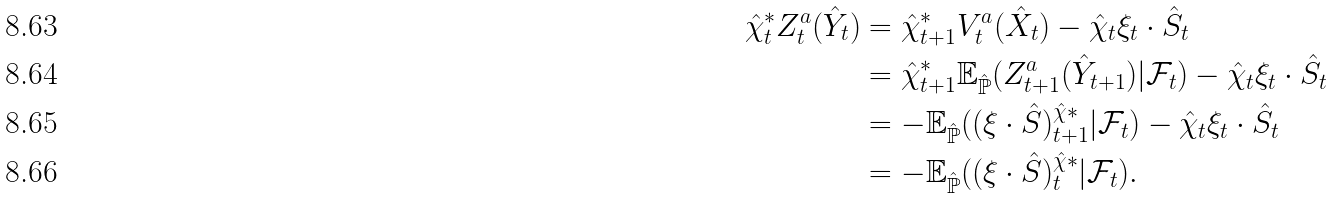Convert formula to latex. <formula><loc_0><loc_0><loc_500><loc_500>\hat { \chi } _ { t } ^ { \ast } Z ^ { a } _ { t } ( \hat { Y } _ { t } ) & = \hat { \chi } _ { t + 1 } ^ { \ast } V ^ { a } _ { t } ( \hat { X } _ { t } ) - \hat { \chi } _ { t } \xi _ { t } \cdot \hat { S } _ { t } \\ & = \hat { \chi } _ { t + 1 } ^ { \ast } \mathbb { E } _ { \hat { \mathbb { P } } } ( Z ^ { a } _ { t + 1 } ( \hat { Y } _ { t + 1 } ) | \mathcal { F } _ { t } ) - \hat { \chi } _ { t } \xi _ { t } \cdot \hat { S } _ { t } \\ & = - \mathbb { E } _ { \hat { \mathbb { P } } } ( ( \xi \cdot \hat { S } ) _ { t + 1 } ^ { \hat { \chi } \ast } | \mathcal { F } _ { t } ) - \hat { \chi } _ { t } \xi _ { t } \cdot \hat { S } _ { t } \\ & = - \mathbb { E } _ { \hat { \mathbb { P } } } ( ( \xi \cdot \hat { S } ) _ { t } ^ { \hat { \chi } \ast } | \mathcal { F } _ { t } ) .</formula> 